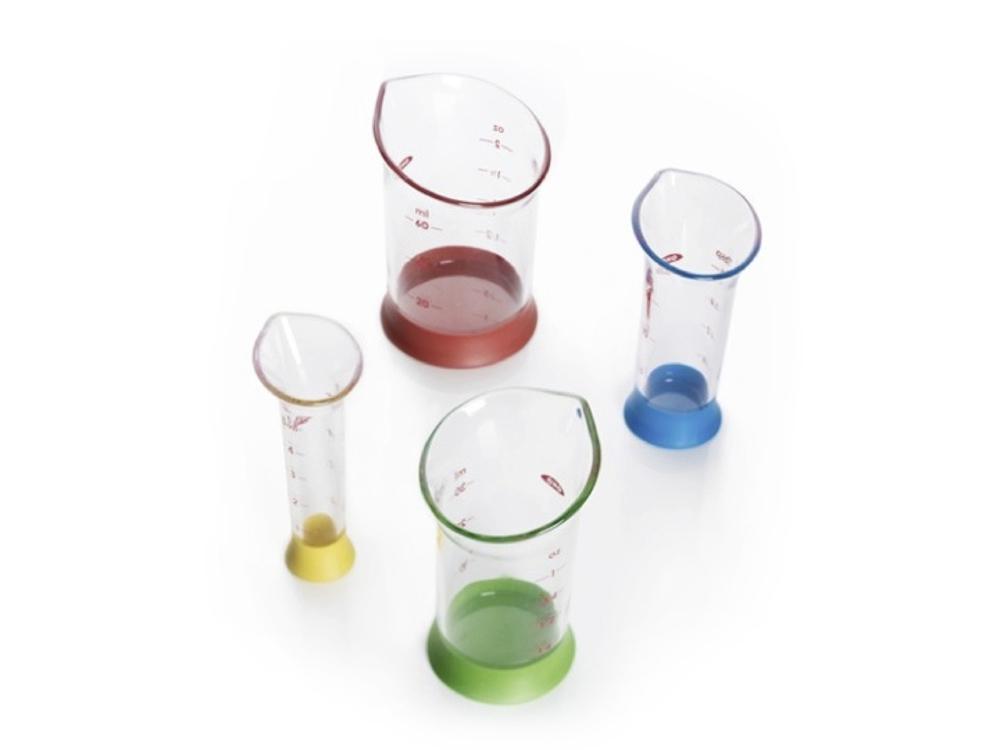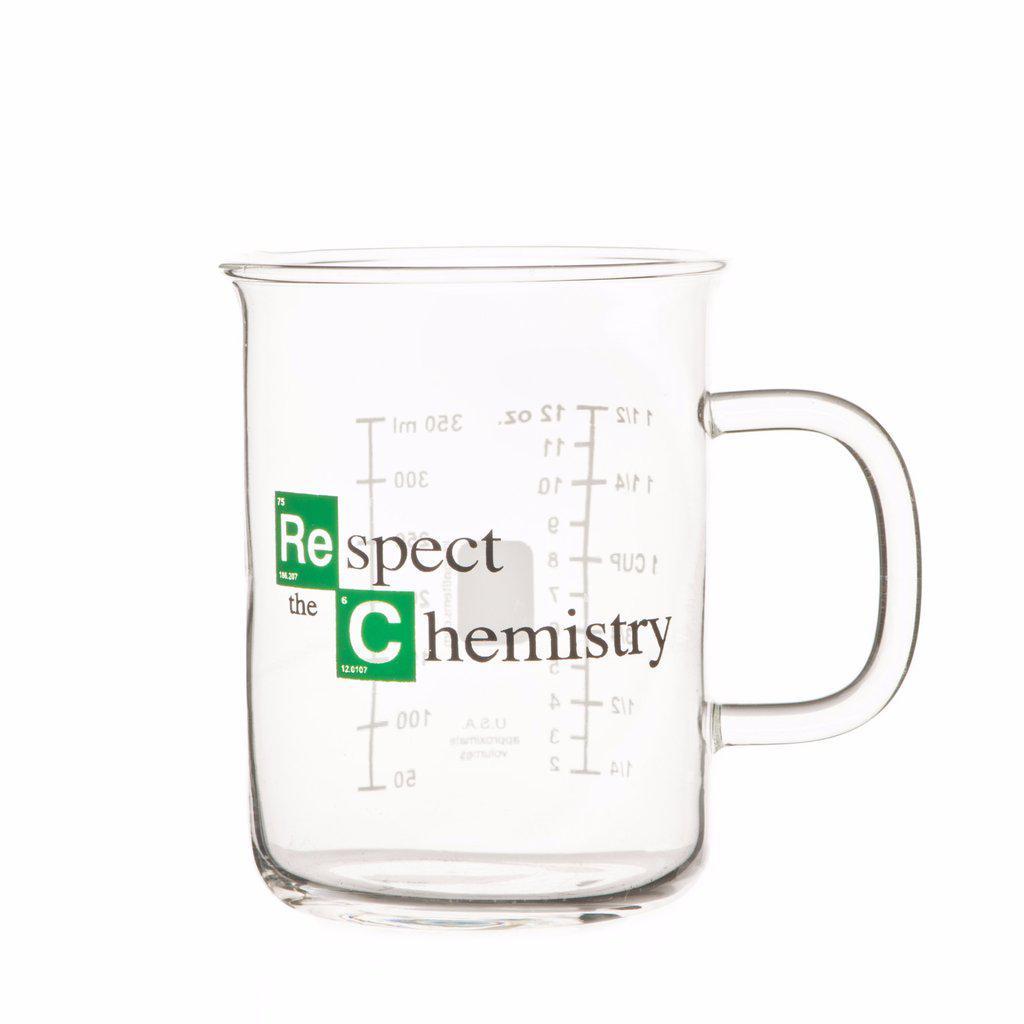The first image is the image on the left, the second image is the image on the right. Assess this claim about the two images: "The image to the left contains a flask with a blue tinted liquid inside.". Correct or not? Answer yes or no. No. The first image is the image on the left, the second image is the image on the right. Assess this claim about the two images: "There is no less than one clear beaker filled with a blue liquid". Correct or not? Answer yes or no. No. 